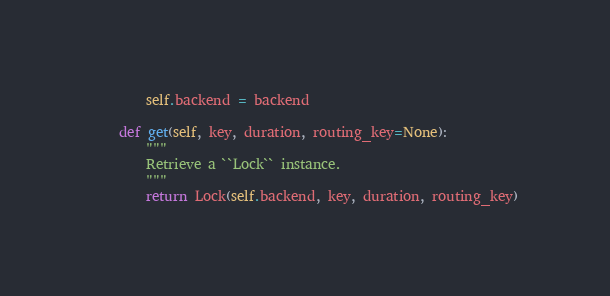Convert code to text. <code><loc_0><loc_0><loc_500><loc_500><_Python_>        self.backend = backend

    def get(self, key, duration, routing_key=None):
        """
        Retrieve a ``Lock`` instance.
        """
        return Lock(self.backend, key, duration, routing_key)
</code> 